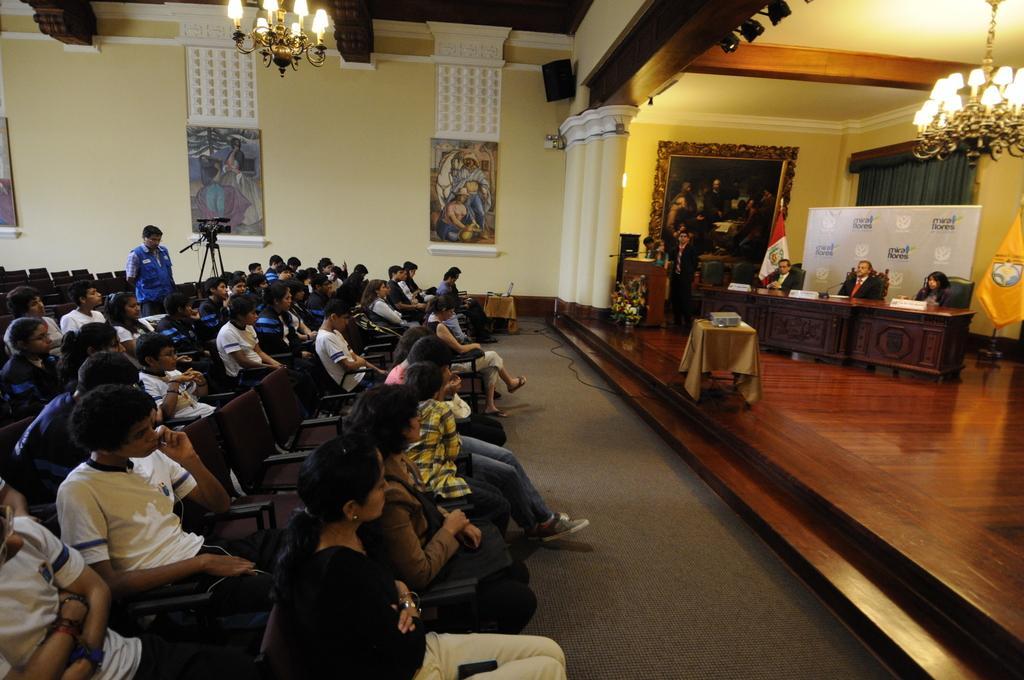In one or two sentences, can you explain what this image depicts? As we can see in the image there are few people here and there sitting on chairs, wall, chandeliers, banners, photo frames and camera over here. 